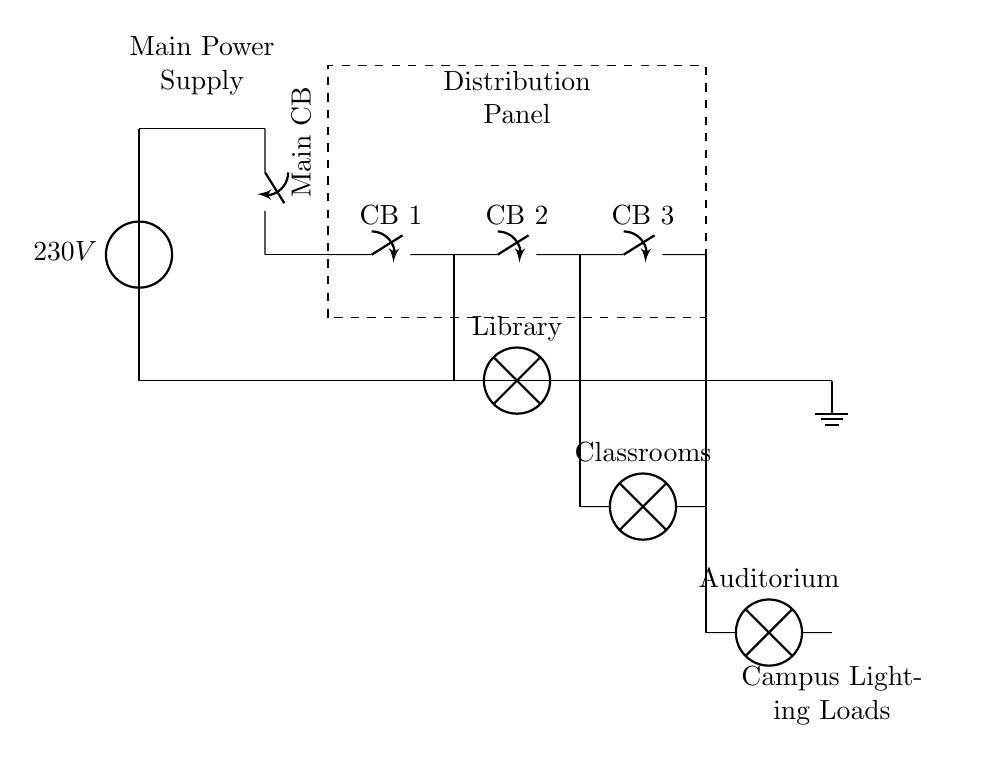What is the main voltage supplied to the circuit? The main voltage is indicated as 230V in the diagram, directly saying the voltage connected to the power source.
Answer: 230V What are the connected lighting loads in this circuit? The lighting loads include the Library, Classrooms, and Auditorium, which are shown as lamps in the circuit diagram.
Answer: Library, Classrooms, Auditorium How many circuit breakers are present in the distribution panel? There are three circuit breakers labeled as CB 1, CB 2, and CB 3, which can be counted from the diagram in the distribution panel section.
Answer: 3 What is the purpose of the main circuit breaker in the circuit? The main circuit breaker serves to interrupt the circuit during overloads or faults, protecting the whole system from damage.
Answer: Protection What is the connection type used for the lights at the Library? The connection for the Library light is a series connection from the circuit breaker to the lamp, as shown by the lines leading to the lamp symbol.
Answer: Series Which component is used to ground the circuit? The circuit utilizes a ground symbol at the end of the circuit to indicate where the circuit is grounded for safety.
Answer: Ground What type of circuit is depicted in this diagram? The circuit described is a power distribution circuit specifically designed to deliver power to multiple lighting fixtures across a campus.
Answer: Power distribution circuit 